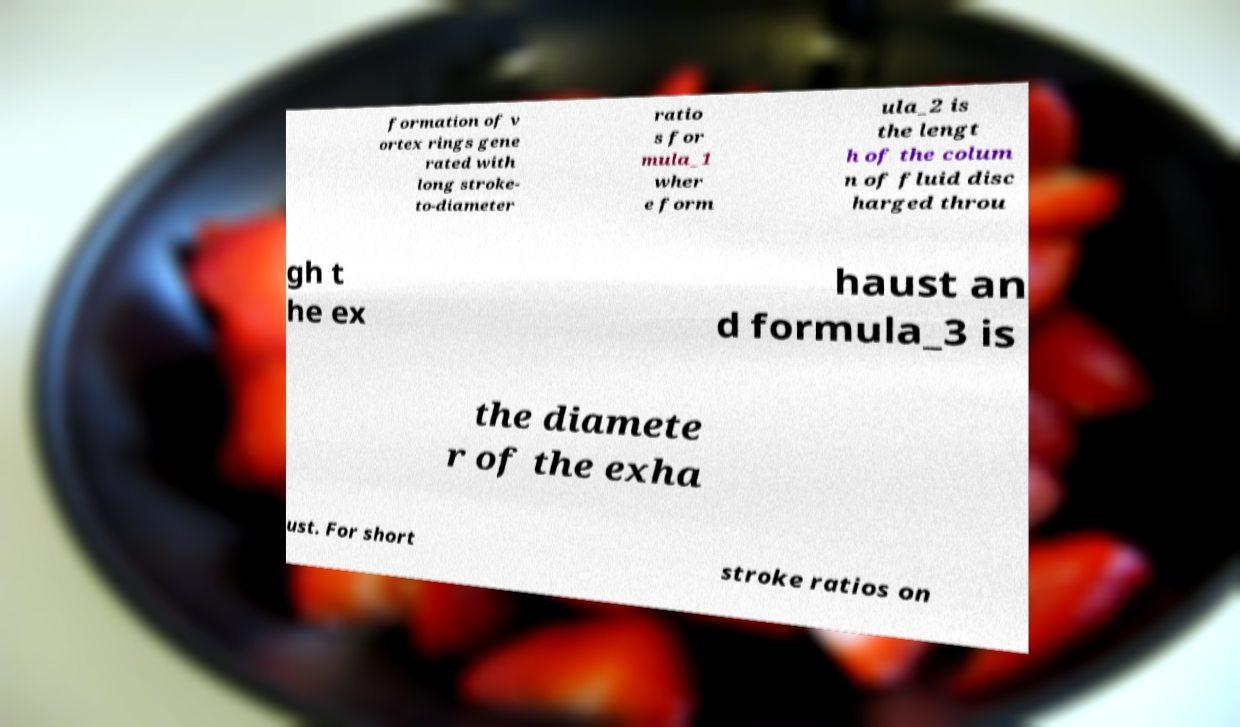Could you extract and type out the text from this image? formation of v ortex rings gene rated with long stroke- to-diameter ratio s for mula_1 wher e form ula_2 is the lengt h of the colum n of fluid disc harged throu gh t he ex haust an d formula_3 is the diamete r of the exha ust. For short stroke ratios on 